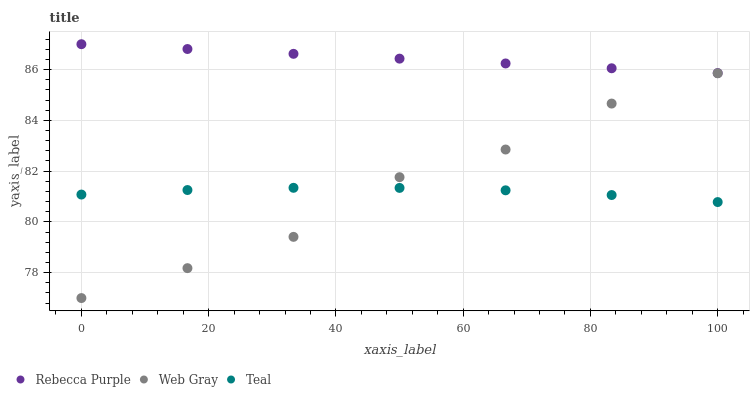Does Teal have the minimum area under the curve?
Answer yes or no. Yes. Does Rebecca Purple have the maximum area under the curve?
Answer yes or no. Yes. Does Rebecca Purple have the minimum area under the curve?
Answer yes or no. No. Does Teal have the maximum area under the curve?
Answer yes or no. No. Is Rebecca Purple the smoothest?
Answer yes or no. Yes. Is Web Gray the roughest?
Answer yes or no. Yes. Is Teal the smoothest?
Answer yes or no. No. Is Teal the roughest?
Answer yes or no. No. Does Web Gray have the lowest value?
Answer yes or no. Yes. Does Teal have the lowest value?
Answer yes or no. No. Does Rebecca Purple have the highest value?
Answer yes or no. Yes. Does Teal have the highest value?
Answer yes or no. No. Is Teal less than Rebecca Purple?
Answer yes or no. Yes. Is Rebecca Purple greater than Teal?
Answer yes or no. Yes. Does Web Gray intersect Teal?
Answer yes or no. Yes. Is Web Gray less than Teal?
Answer yes or no. No. Is Web Gray greater than Teal?
Answer yes or no. No. Does Teal intersect Rebecca Purple?
Answer yes or no. No. 